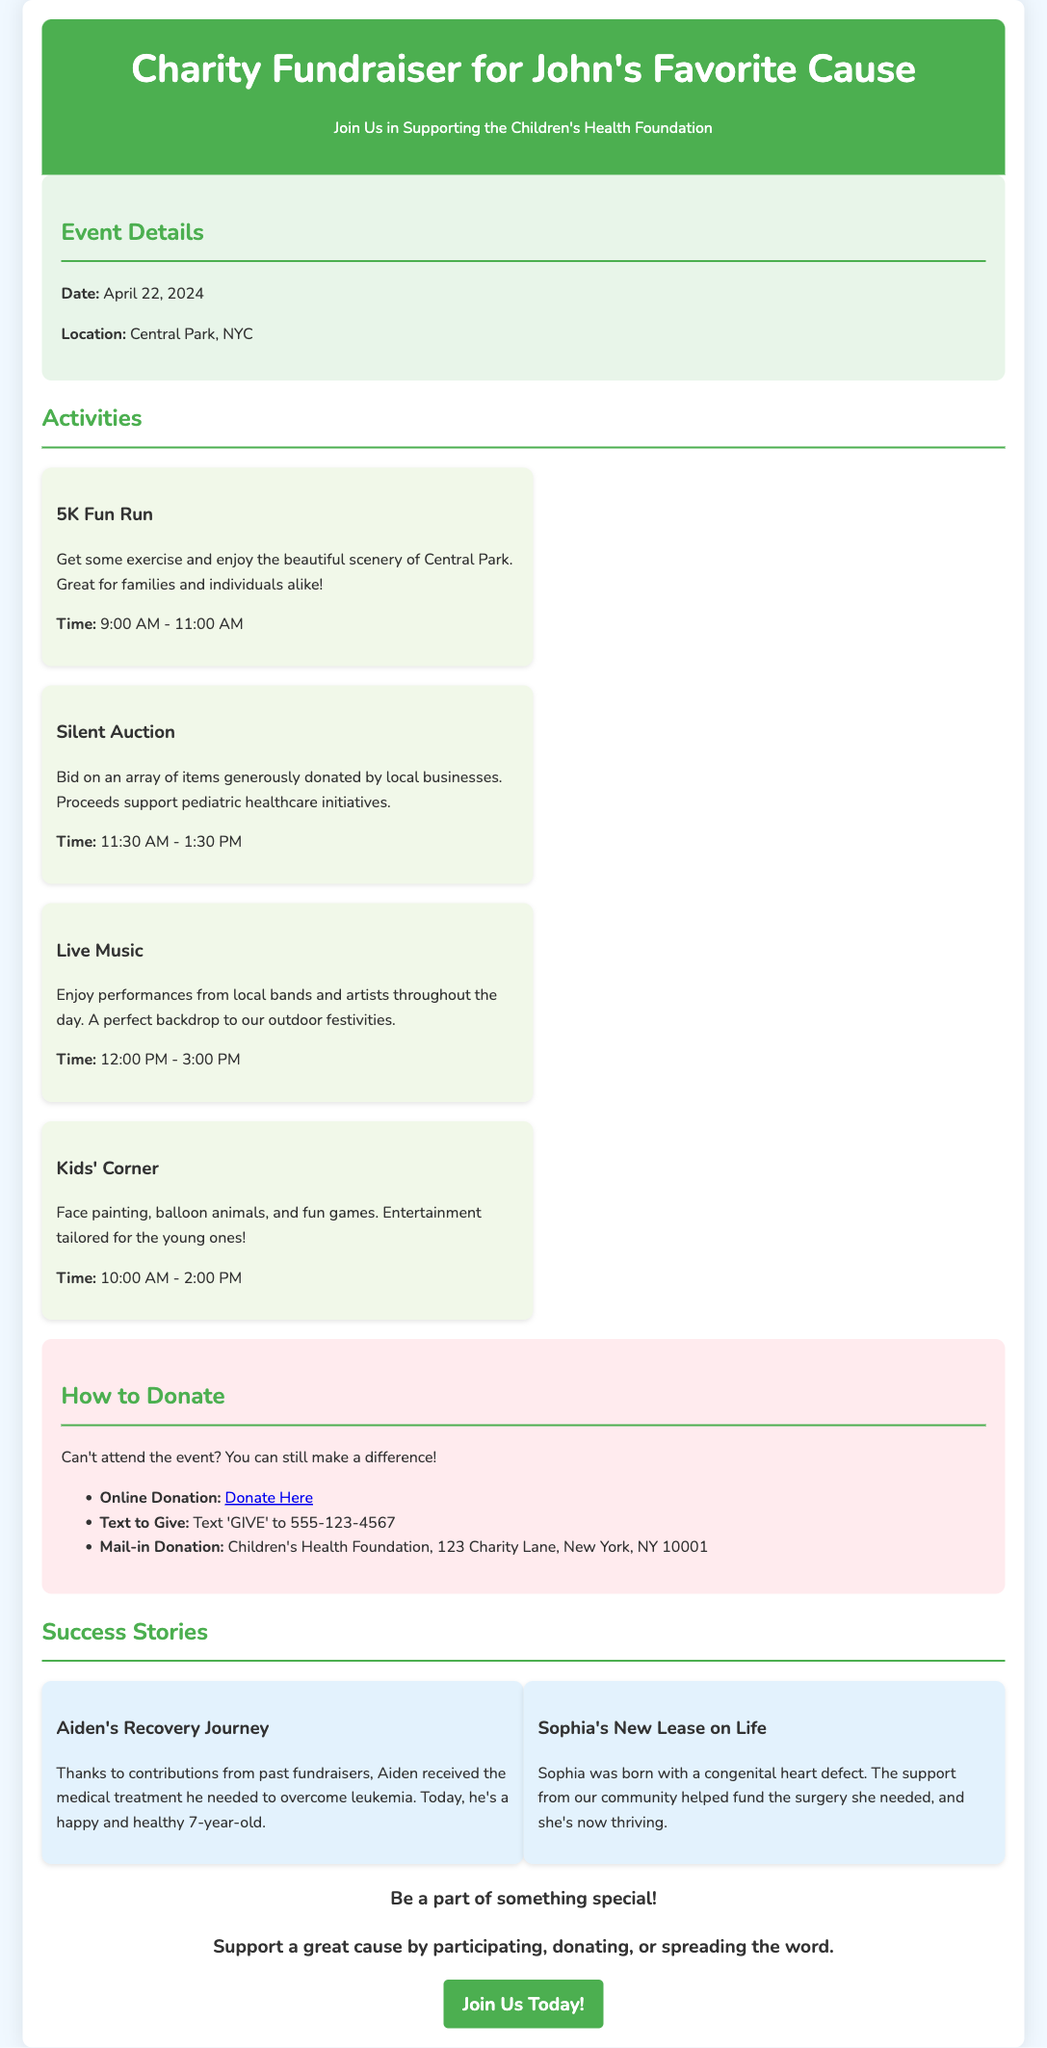What is the event date? The event date is clearly listed under 'Event Details' in the document.
Answer: April 22, 2024 Where is the fundraiser taking place? The location of the event is specified under 'Event Details.'
Answer: Central Park, NYC What is one activity happening at the event? The document lists several activities under the 'Activities' section.
Answer: 5K Fun Run How can I donate online? The 'How to Donate' section gives clear instructions on how to donate online.
Answer: Donate Here What time does the Silent Auction start? The starting time for the Silent Auction is provided in the description of the activity.
Answer: 11:30 AM What is one success story shared in the document? The 'Success Stories' section includes the experiences of individuals helped by past fundraisers.
Answer: Aiden's Recovery Journey What type of event is being organized? The event type is highlighted in the title and throughout the document.
Answer: Charity Fundraiser How can I participate if I can't attend? The 'How to Donate' section directly addresses alternative participation methods for those unable to attend.
Answer: Make a donation online 